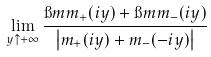Convert formula to latex. <formula><loc_0><loc_0><loc_500><loc_500>\lim _ { y \uparrow + \infty } \frac { \i m m _ { + } ( i y ) + \i m m _ { - } ( i y ) } { \left | m _ { + } ( i y ) + m _ { - } ( - i y ) \right | }</formula> 